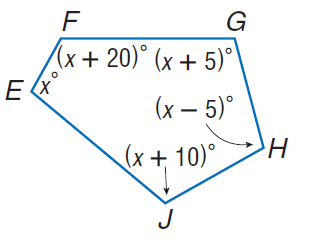Answer the mathemtical geometry problem and directly provide the correct option letter.
Question: Find m \angle F.
Choices: A: 102 B: 107 C: 112 D: 122 D 